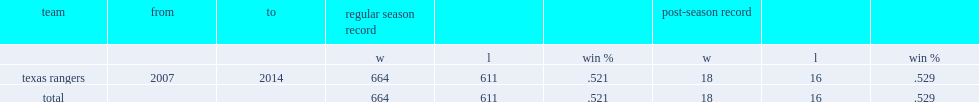I'm looking to parse the entire table for insights. Could you assist me with that? {'header': ['team', 'from', 'to', 'regular season record', '', '', 'post-season record', '', ''], 'rows': [['', '', '', 'w', 'l', 'win %', 'w', 'l', 'win %'], ['texas rangers', '2007', '2014', '664', '611', '.521', '18', '16', '.529'], ['total', '', '', '664', '611', '.521', '18', '16', '.529']]} What was rangers's winning percentage in regular season? 0.521. 